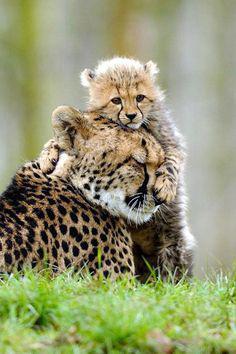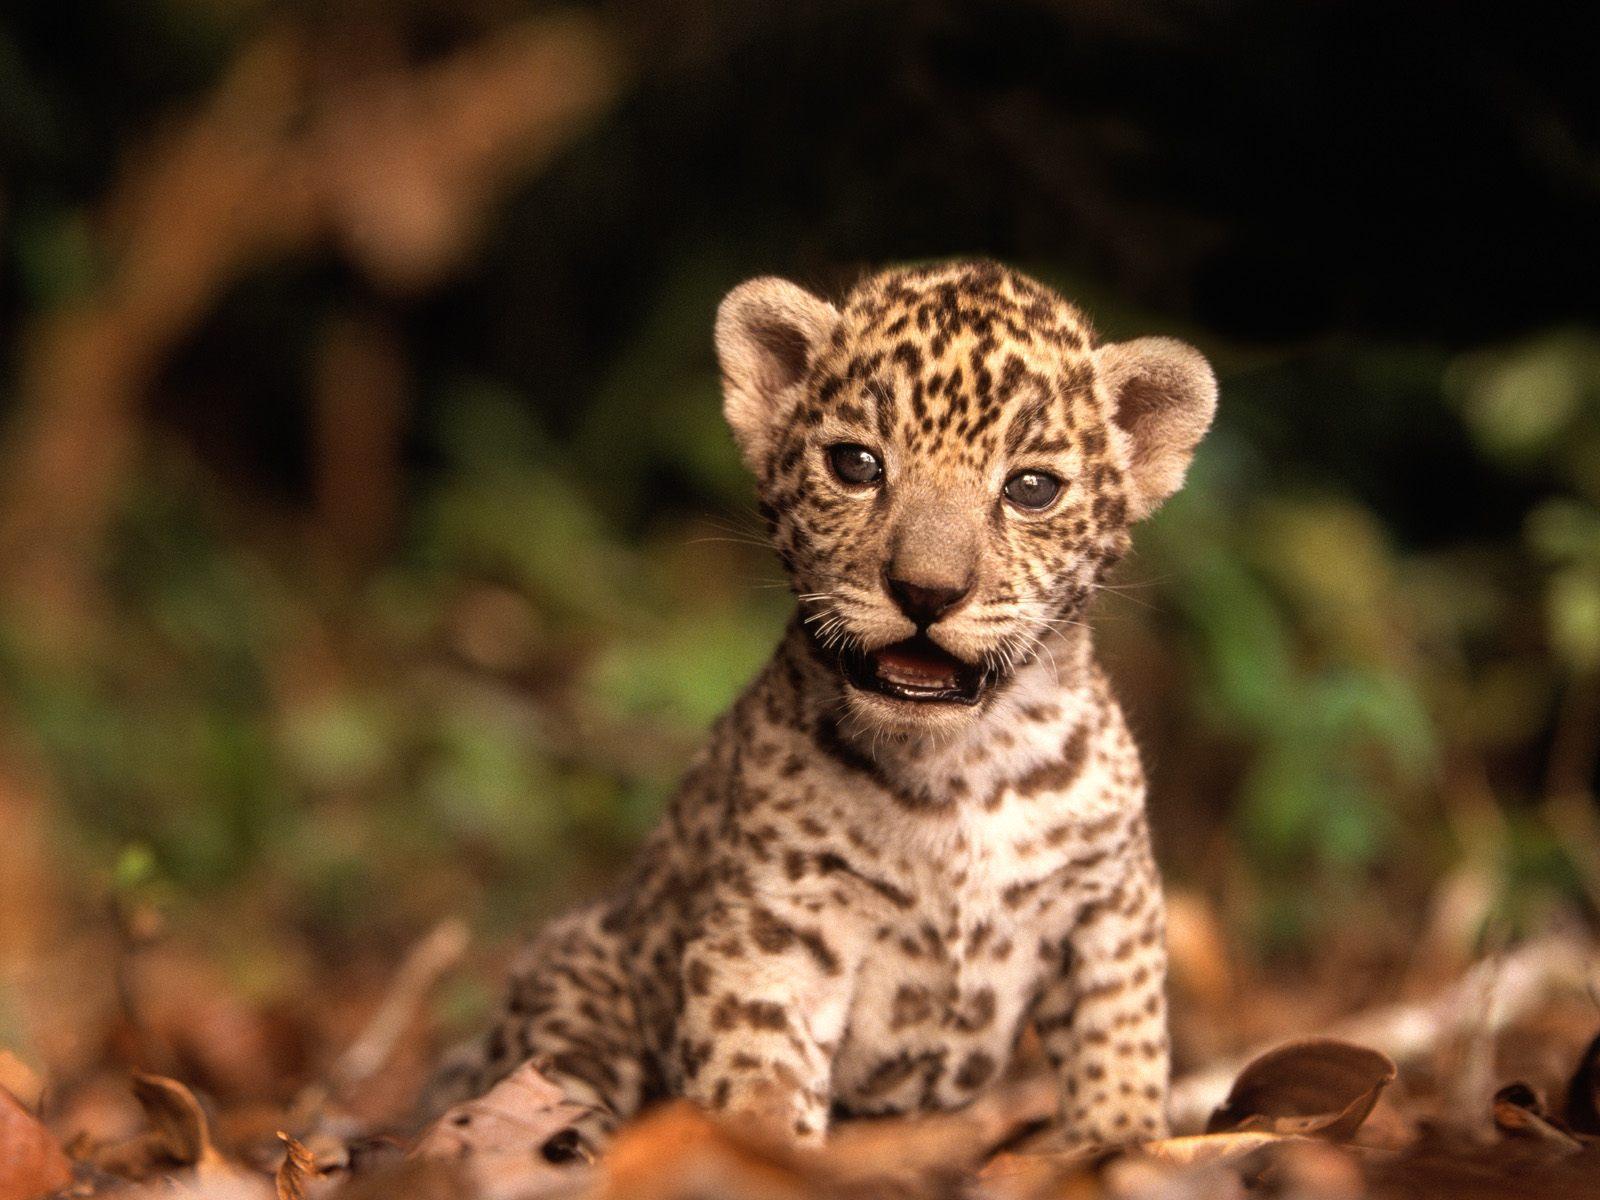The first image is the image on the left, the second image is the image on the right. Examine the images to the left and right. Is the description "At least one baby cheetah is looking straight into the camera." accurate? Answer yes or no. Yes. The first image is the image on the left, the second image is the image on the right. Assess this claim about the two images: "One image features exactly one young cheetah next to an adult cheetah sitting upright with its head and body facing right.". Correct or not? Answer yes or no. No. 